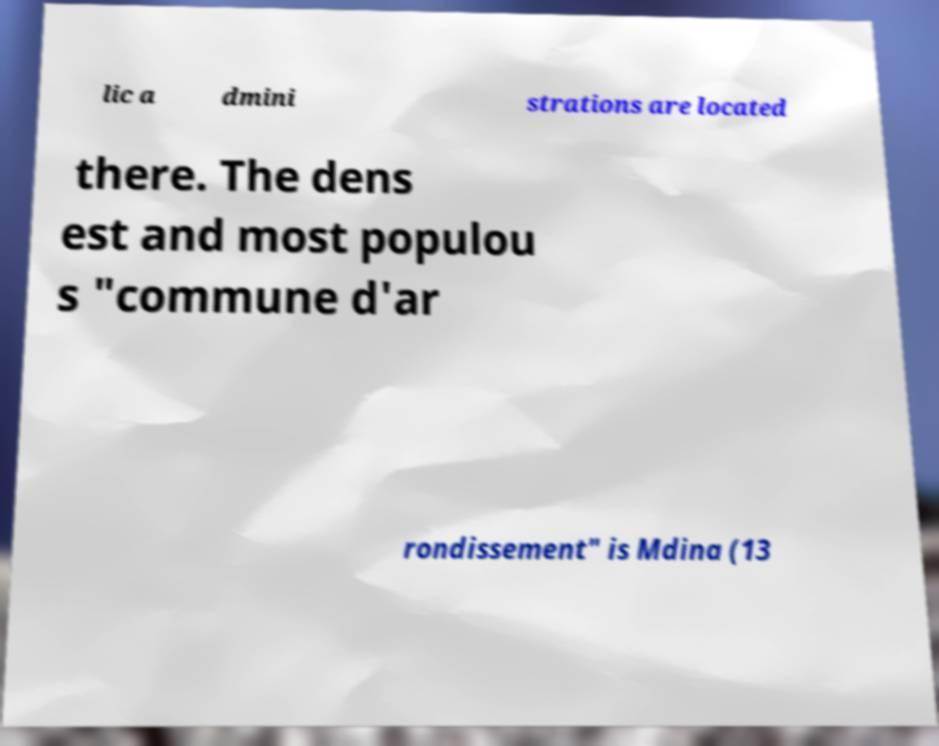Can you accurately transcribe the text from the provided image for me? lic a dmini strations are located there. The dens est and most populou s "commune d'ar rondissement" is Mdina (13 